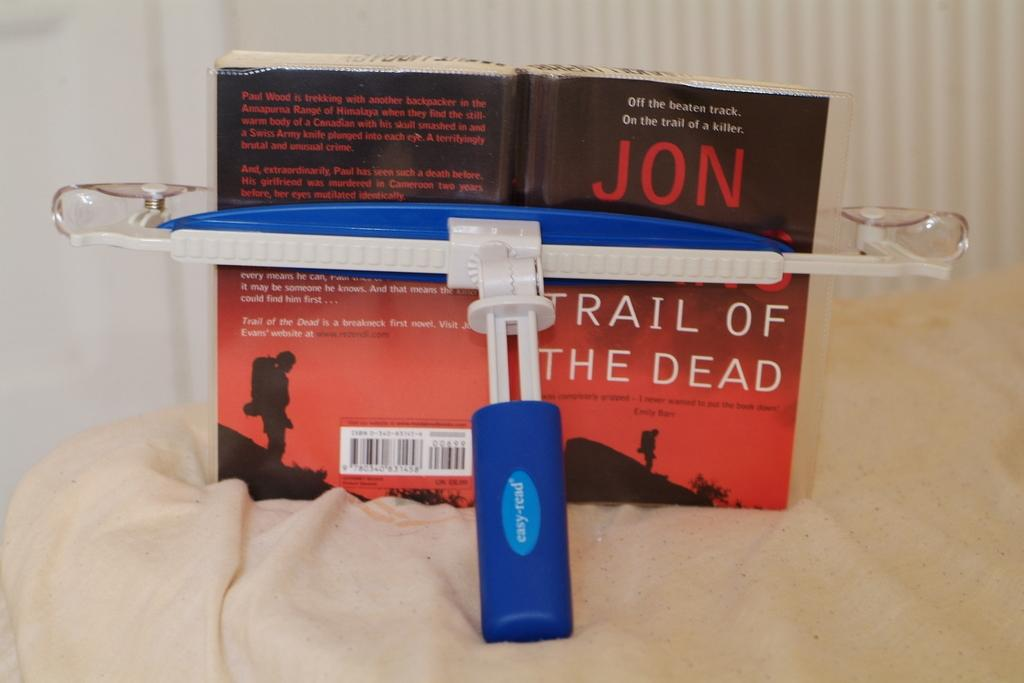<image>
Create a compact narrative representing the image presented. A book light and book entitled Jon Trail of the Dead. 